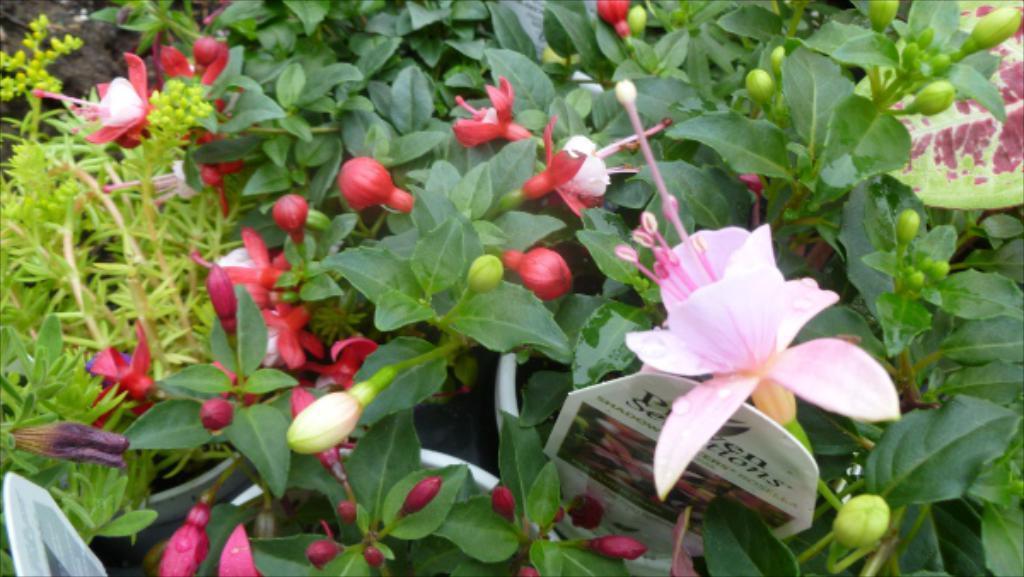Could you give a brief overview of what you see in this image? These are the plants with the flowers, buds and leaves. I can see the flower pots. This looks like a card. 